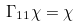Convert formula to latex. <formula><loc_0><loc_0><loc_500><loc_500>\Gamma _ { 1 1 } \chi = \chi</formula> 